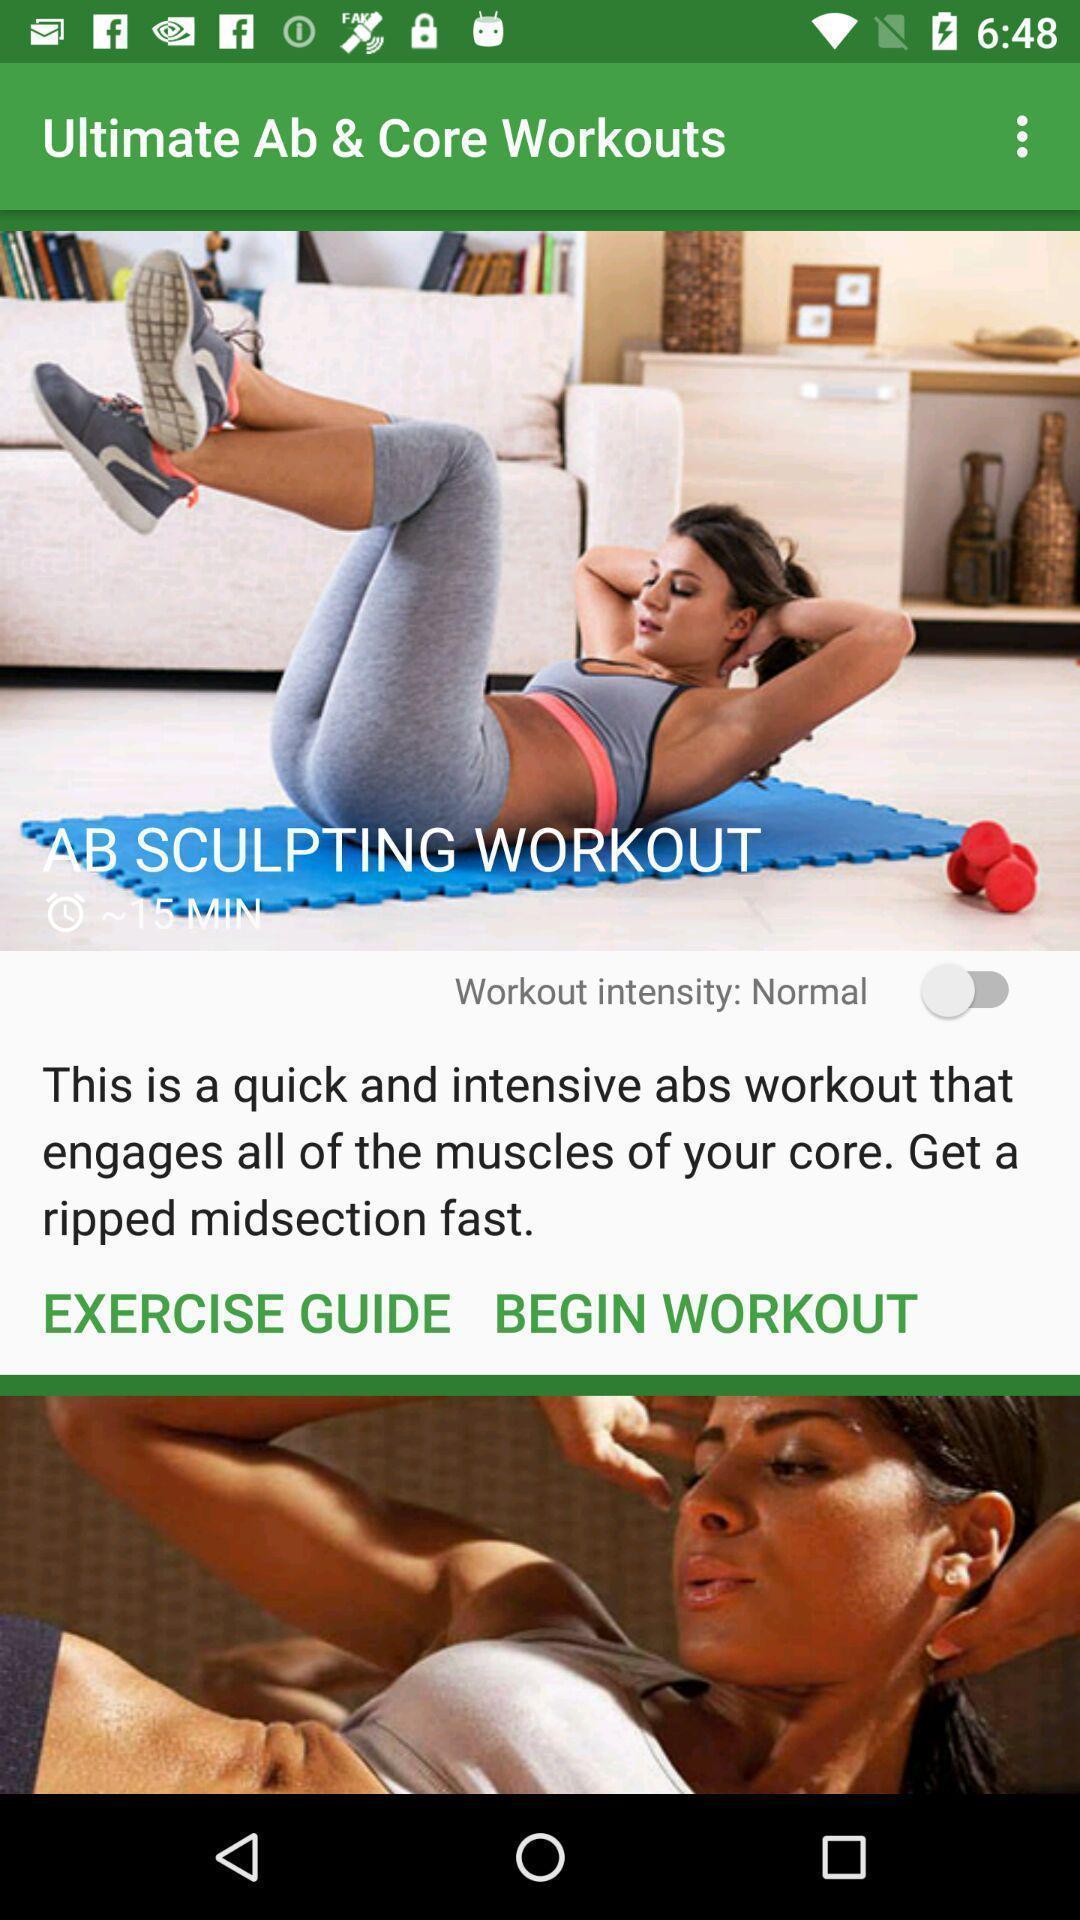Give me a summary of this screen capture. Page showing the thumbnails in fitness app. 